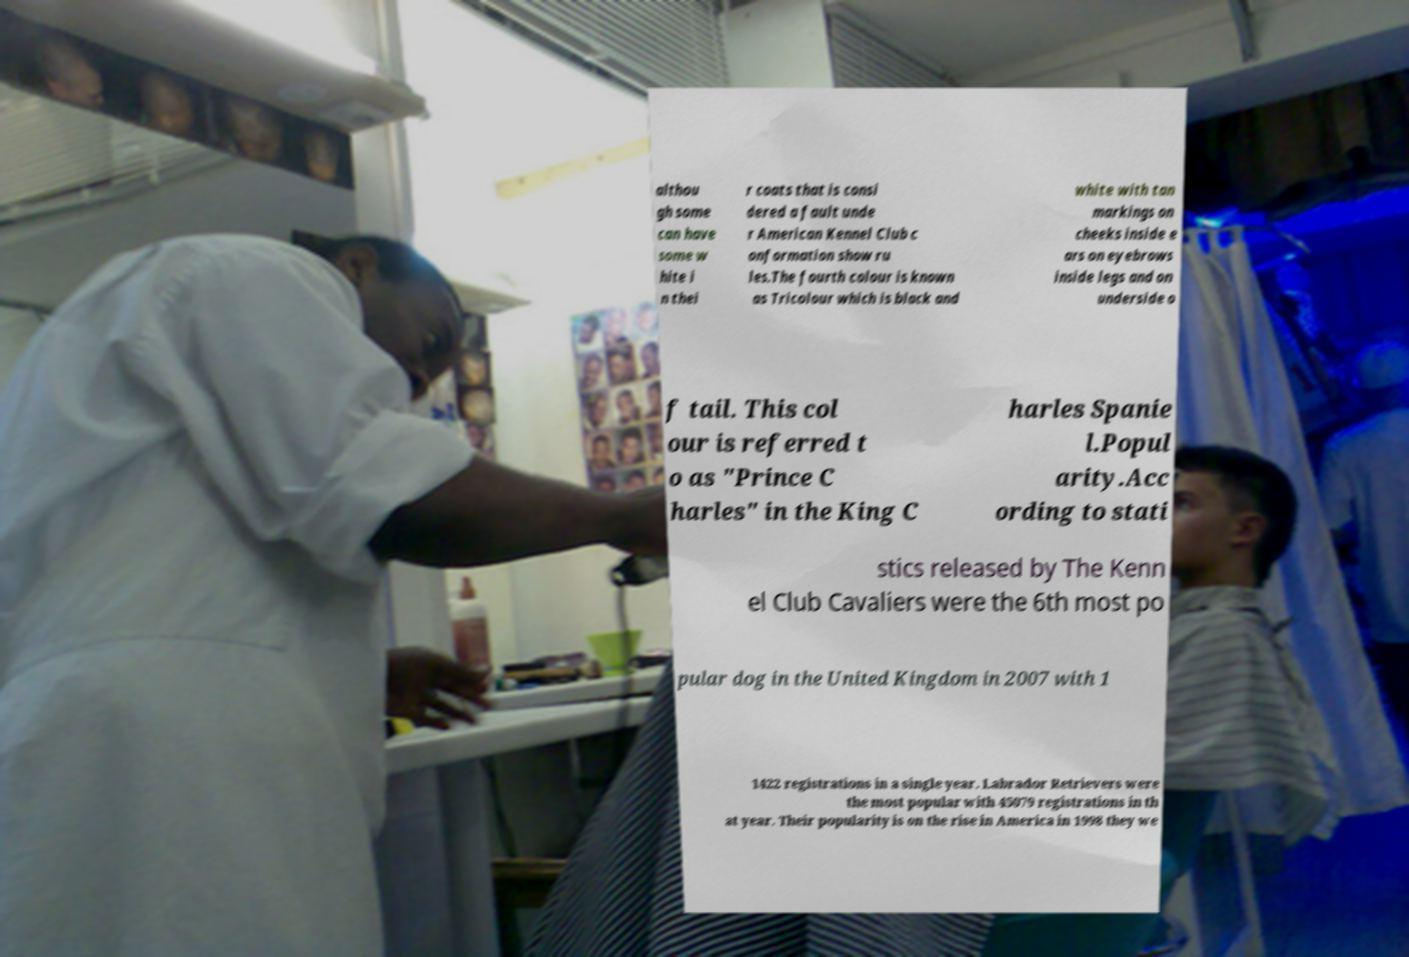Please read and relay the text visible in this image. What does it say? althou gh some can have some w hite i n thei r coats that is consi dered a fault unde r American Kennel Club c onformation show ru les.The fourth colour is known as Tricolour which is black and white with tan markings on cheeks inside e ars on eyebrows inside legs and on underside o f tail. This col our is referred t o as "Prince C harles" in the King C harles Spanie l.Popul arity.Acc ording to stati stics released by The Kenn el Club Cavaliers were the 6th most po pular dog in the United Kingdom in 2007 with 1 1422 registrations in a single year. Labrador Retrievers were the most popular with 45079 registrations in th at year. Their popularity is on the rise in America in 1998 they we 